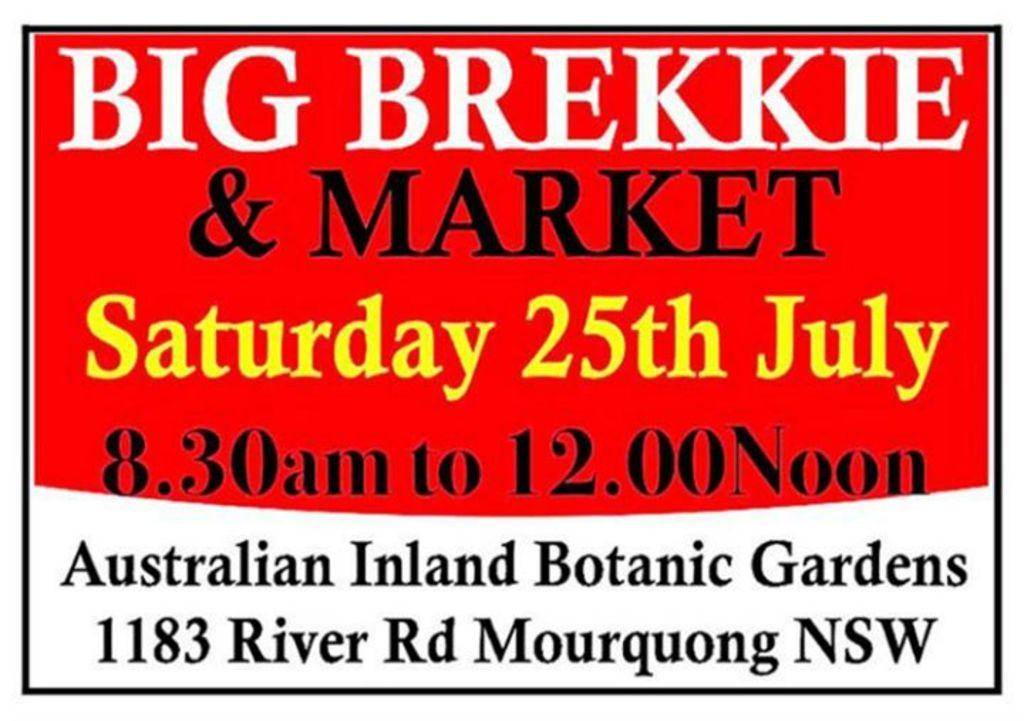<image>
Render a clear and concise summary of the photo. An advertisement for big brekkie and market with an event happening on Saturday. 